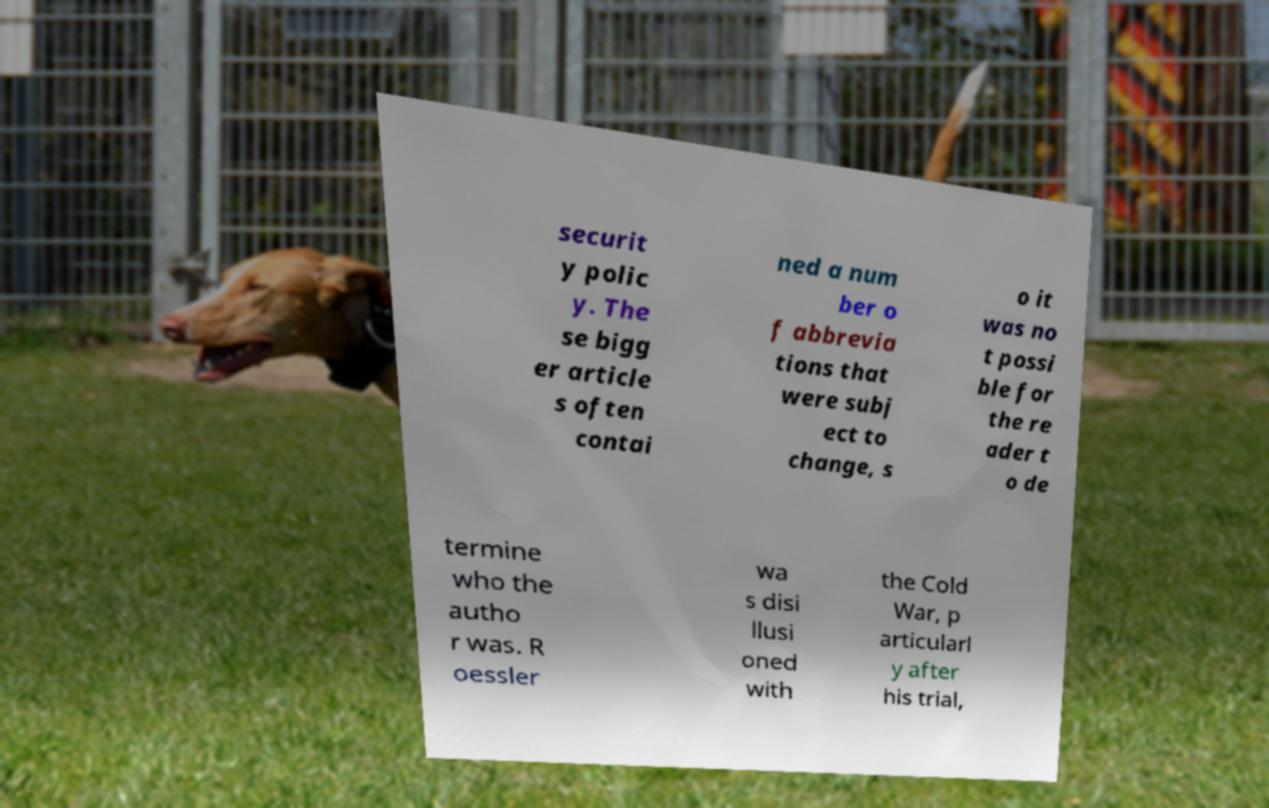Can you accurately transcribe the text from the provided image for me? securit y polic y. The se bigg er article s often contai ned a num ber o f abbrevia tions that were subj ect to change, s o it was no t possi ble for the re ader t o de termine who the autho r was. R oessler wa s disi llusi oned with the Cold War, p articularl y after his trial, 